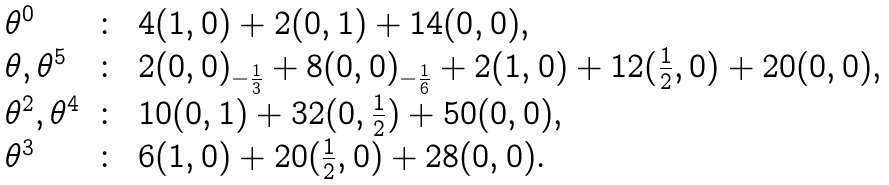Convert formula to latex. <formula><loc_0><loc_0><loc_500><loc_500>\begin{array} { l c l } \theta ^ { 0 } & \colon & 4 ( 1 , 0 ) + 2 ( 0 , 1 ) + 1 4 ( 0 , 0 ) , \\ \theta , \theta ^ { 5 } & \colon & 2 ( 0 , 0 ) _ { - \frac { 1 } { 3 } } + 8 ( 0 , 0 ) _ { - \frac { 1 } { 6 } } + 2 ( 1 , 0 ) + 1 2 ( \frac { 1 } { 2 } , 0 ) + 2 0 ( 0 , 0 ) , \\ \theta ^ { 2 } , \theta ^ { 4 } & \colon & 1 0 ( 0 , 1 ) + 3 2 ( 0 , \frac { 1 } { 2 } ) + 5 0 ( 0 , 0 ) , \\ \theta ^ { 3 } & \colon & 6 ( 1 , 0 ) + 2 0 ( \frac { 1 } { 2 } , 0 ) + 2 8 ( 0 , 0 ) . \end{array}</formula> 